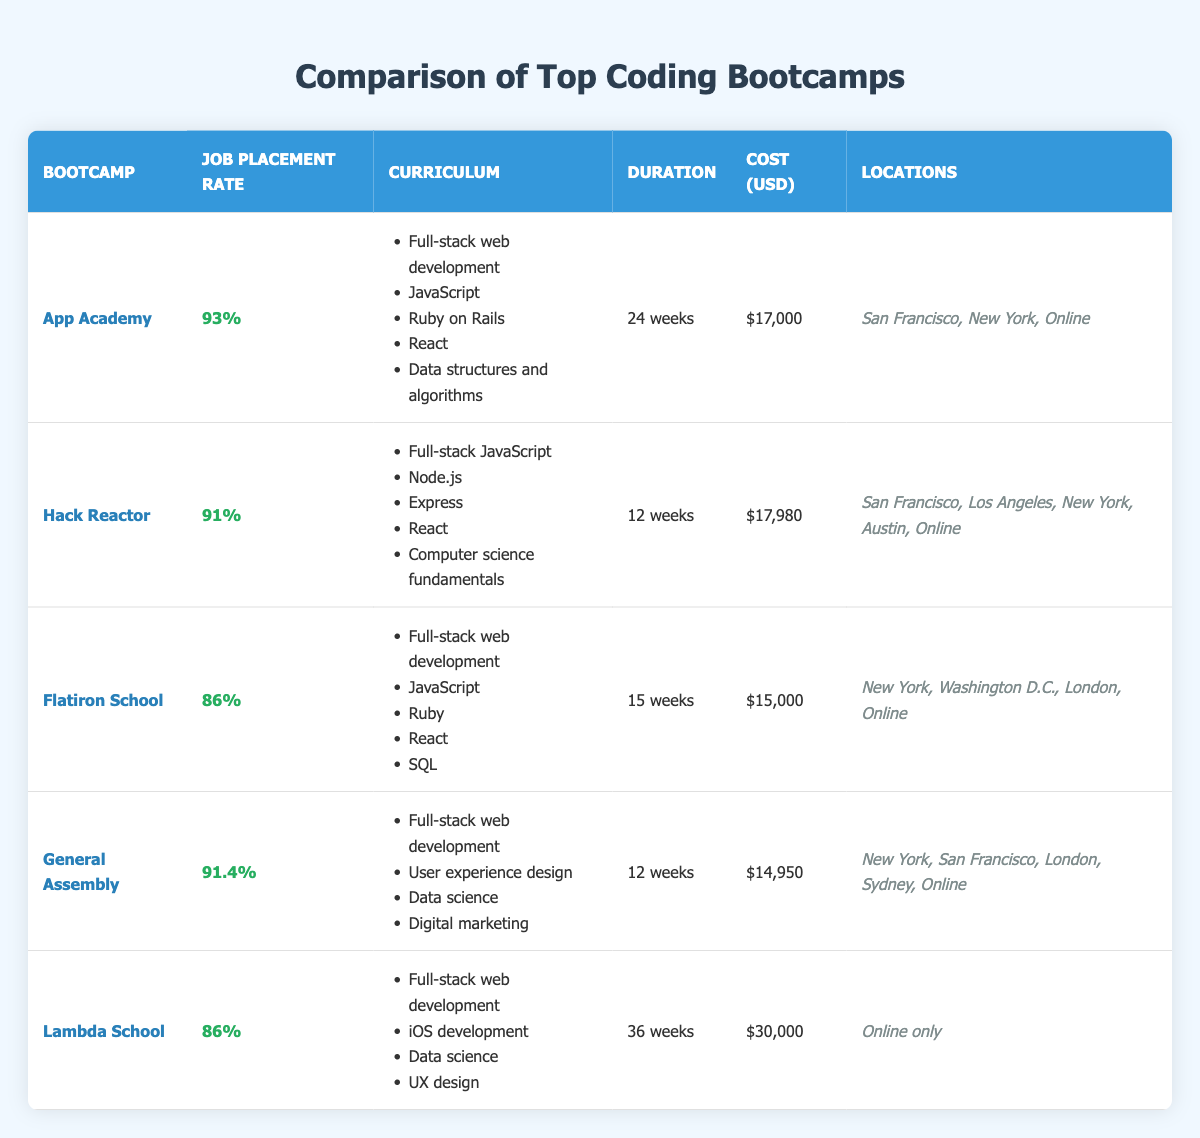What is the job placement rate for App Academy? The job placement rate for App Academy is directly listed in the table, which shows it is 93%.
Answer: 93% Which bootcamp has the highest job placement rate? By comparing the job placement rates in the table, App Academy has the highest at 93%.
Answer: App Academy What is the duration of the Flatiron School program? The duration of the Flatiron School program is shown in the table as 15 weeks.
Answer: 15 weeks How many bootcamps have a job placement rate above 90%? Looking at the job placement rates, I see that App Academy (93%), General Assembly (91.4%), and Hack Reactor (91%) all exceed 90%. Thus, there are three bootcamps with such rates.
Answer: 3 What is the average cost of the bootcamps listed? The costs in the table are $17,000, $17,980, $15,000, $14,950, and $30,000. Summing these amounts gives $94,930. There are 5 bootcamps, so the average cost is $94,930 divided by 5, which is $18,986.
Answer: $18,986 Does Lambda School have a program duration of less than 30 weeks? Referring to the table, Lambda School's duration is 36 weeks, which is greater than 30 weeks. Therefore, the answer is no.
Answer: No What curriculum topics are unique to Hack Reactor compared to Flatiron School? Comparing the curriculums: Hack Reactor includes Node.js, Express, and Computer science fundamentals, which are not present in Flatiron School's curriculum. Therefore, these three topics are unique to Hack Reactor.
Answer: Node.js, Express, Computer science fundamentals Which bootcamp offers online-only location options? The table specifies that Lambda School is the only bootcamp that offers an online-only program.
Answer: Lambda School What is the difference in job placement rates between General Assembly and Flatiron School? The job placement rate for General Assembly is 91.4% and for Flatiron School is 86%. The difference is 91.4% - 86% = 5.4%.
Answer: 5.4% 